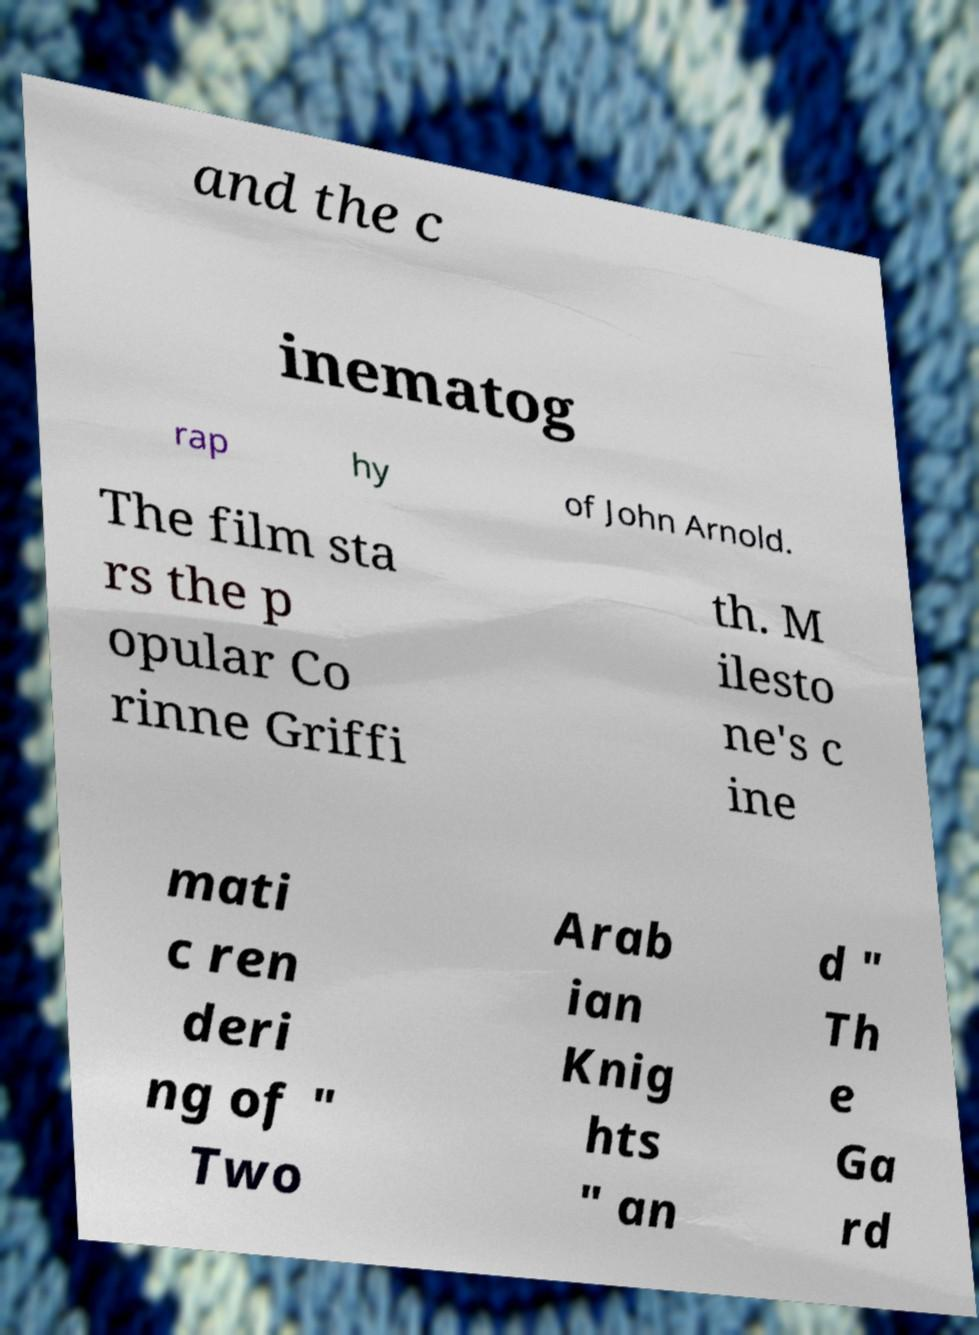What messages or text are displayed in this image? I need them in a readable, typed format. and the c inematog rap hy of John Arnold. The film sta rs the p opular Co rinne Griffi th. M ilesto ne's c ine mati c ren deri ng of " Two Arab ian Knig hts " an d " Th e Ga rd 